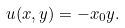Convert formula to latex. <formula><loc_0><loc_0><loc_500><loc_500>u ( x , y ) = - x _ { 0 } y .</formula> 